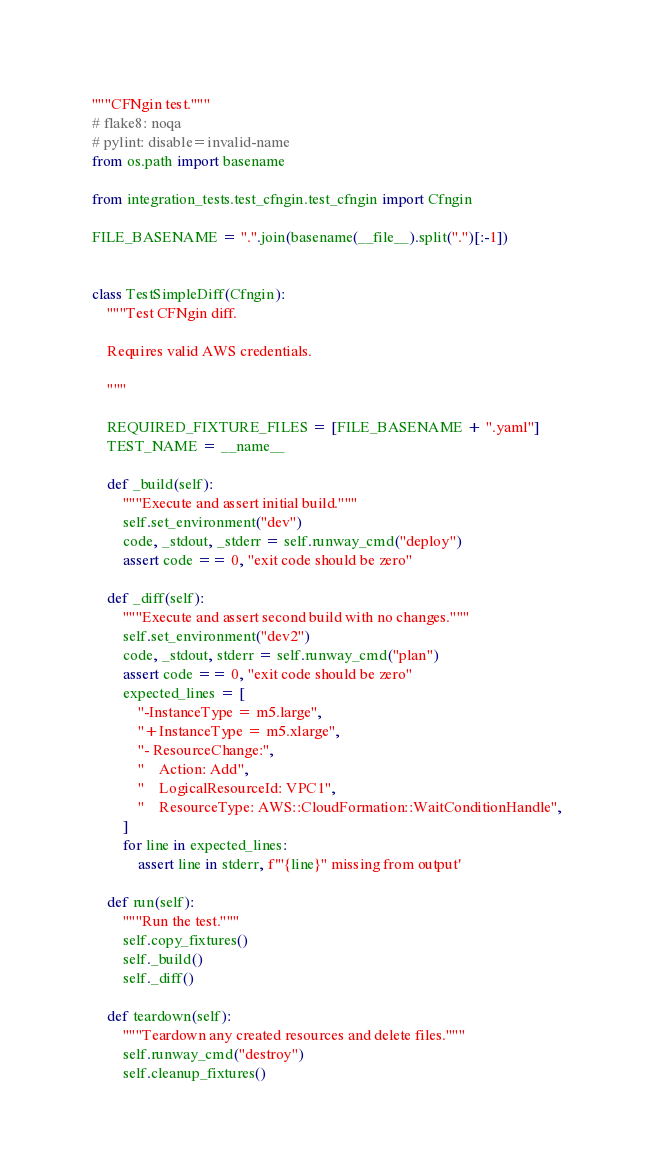Convert code to text. <code><loc_0><loc_0><loc_500><loc_500><_Python_>"""CFNgin test."""
# flake8: noqa
# pylint: disable=invalid-name
from os.path import basename

from integration_tests.test_cfngin.test_cfngin import Cfngin

FILE_BASENAME = ".".join(basename(__file__).split(".")[:-1])


class TestSimpleDiff(Cfngin):
    """Test CFNgin diff.

    Requires valid AWS credentials.

    """

    REQUIRED_FIXTURE_FILES = [FILE_BASENAME + ".yaml"]
    TEST_NAME = __name__

    def _build(self):
        """Execute and assert initial build."""
        self.set_environment("dev")
        code, _stdout, _stderr = self.runway_cmd("deploy")
        assert code == 0, "exit code should be zero"

    def _diff(self):
        """Execute and assert second build with no changes."""
        self.set_environment("dev2")
        code, _stdout, stderr = self.runway_cmd("plan")
        assert code == 0, "exit code should be zero"
        expected_lines = [
            "-InstanceType = m5.large",
            "+InstanceType = m5.xlarge",
            "- ResourceChange:",
            "    Action: Add",
            "    LogicalResourceId: VPC1",
            "    ResourceType: AWS::CloudFormation::WaitConditionHandle",
        ]
        for line in expected_lines:
            assert line in stderr, f'"{line}" missing from output'

    def run(self):
        """Run the test."""
        self.copy_fixtures()
        self._build()
        self._diff()

    def teardown(self):
        """Teardown any created resources and delete files."""
        self.runway_cmd("destroy")
        self.cleanup_fixtures()
</code> 